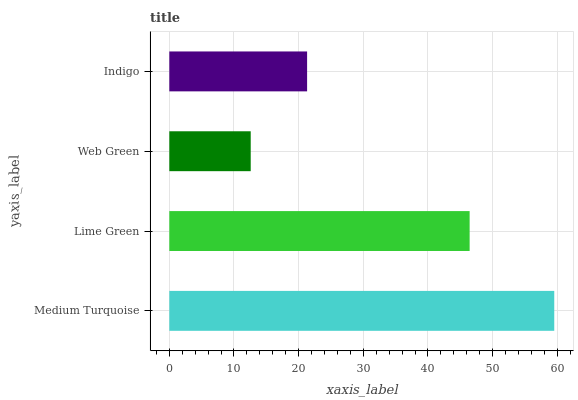Is Web Green the minimum?
Answer yes or no. Yes. Is Medium Turquoise the maximum?
Answer yes or no. Yes. Is Lime Green the minimum?
Answer yes or no. No. Is Lime Green the maximum?
Answer yes or no. No. Is Medium Turquoise greater than Lime Green?
Answer yes or no. Yes. Is Lime Green less than Medium Turquoise?
Answer yes or no. Yes. Is Lime Green greater than Medium Turquoise?
Answer yes or no. No. Is Medium Turquoise less than Lime Green?
Answer yes or no. No. Is Lime Green the high median?
Answer yes or no. Yes. Is Indigo the low median?
Answer yes or no. Yes. Is Web Green the high median?
Answer yes or no. No. Is Web Green the low median?
Answer yes or no. No. 